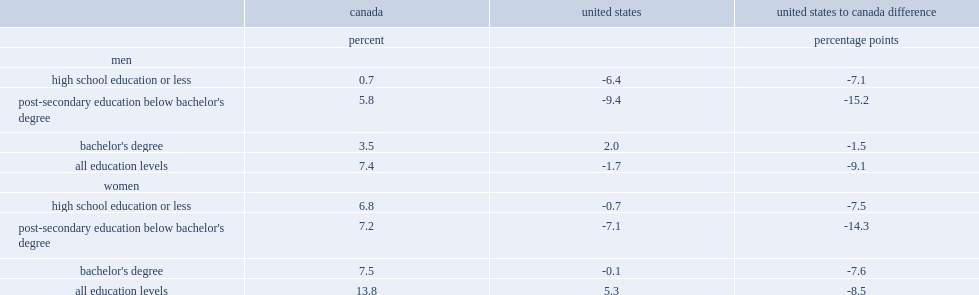Employees with which kind of education especially pronounced the canada-u.s. difference in wage growth from 2000 to 2017? Post-secondary education below bachelor's degree post-secondary education below bachelor's degree. How many percentage points was the real wage growth rate among canadian male bachelor degree holders higher than that of their u.s. counterparts from 2000 to 2017? 1.5. Could you parse the entire table as a dict? {'header': ['', 'canada', 'united states', 'united states to canada difference'], 'rows': [['', 'percent', '', 'percentage points'], ['men', '', '', ''], ['high school education or less', '0.7', '-6.4', '-7.1'], ["post-secondary education below bachelor's degree", '5.8', '-9.4', '-15.2'], ["bachelor's degree", '3.5', '2.0', '-1.5'], ['all education levels', '7.4', '-1.7', '-9.1'], ['women', '', '', ''], ['high school education or less', '6.8', '-0.7', '-7.5'], ["post-secondary education below bachelor's degree", '7.2', '-7.1', '-14.3'], ["bachelor's degree", '7.5', '-0.1', '-7.6'], ['all education levels', '13.8', '5.3', '-8.5']]} 